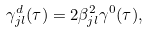Convert formula to latex. <formula><loc_0><loc_0><loc_500><loc_500>\gamma _ { j l } ^ { d } ( \tau ) = 2 \beta ^ { 2 } _ { j l } \gamma ^ { 0 } ( \tau ) ,</formula> 